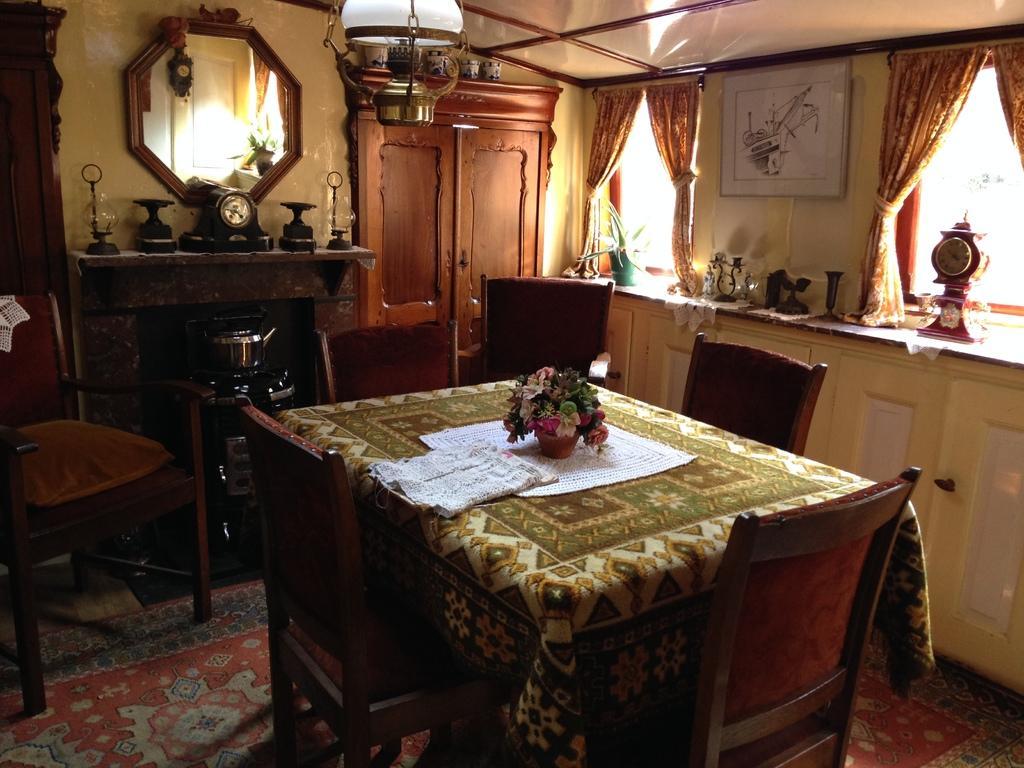Could you give a brief overview of what you see in this image? In this picture we can see the chairs and table. There is a plant, cloth and other object on the table. On the right we can see the clock, papers and other objects near to the window. In the back there is a door. On the left there is a fireplace. At the top there is a candler. In the top left corner we can see the mirror. In the bottom left there is a carpet. 